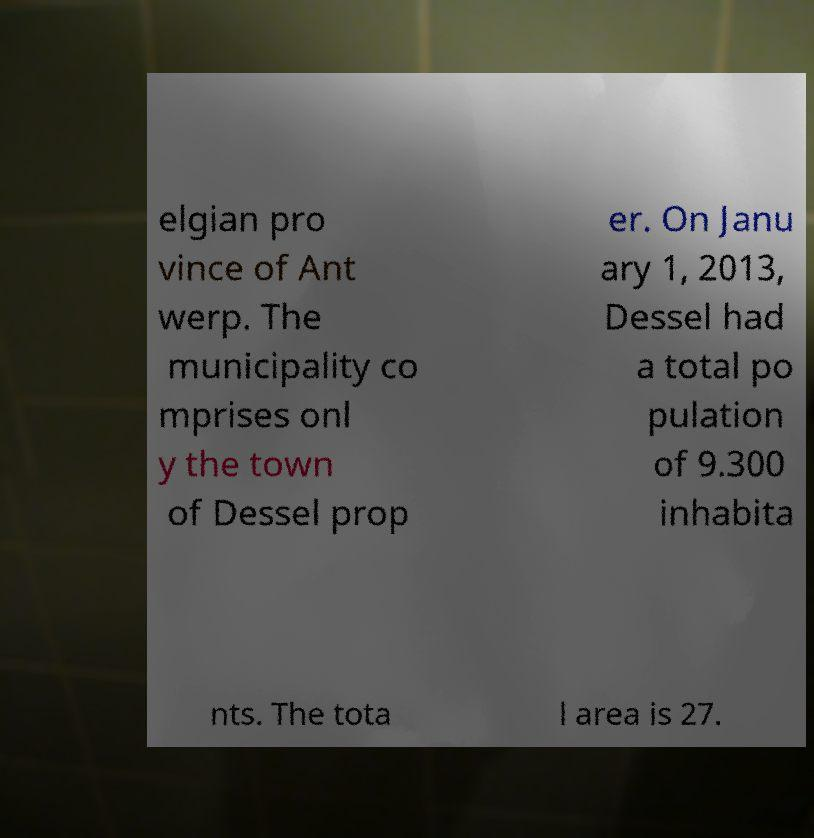Please read and relay the text visible in this image. What does it say? elgian pro vince of Ant werp. The municipality co mprises onl y the town of Dessel prop er. On Janu ary 1, 2013, Dessel had a total po pulation of 9.300 inhabita nts. The tota l area is 27. 